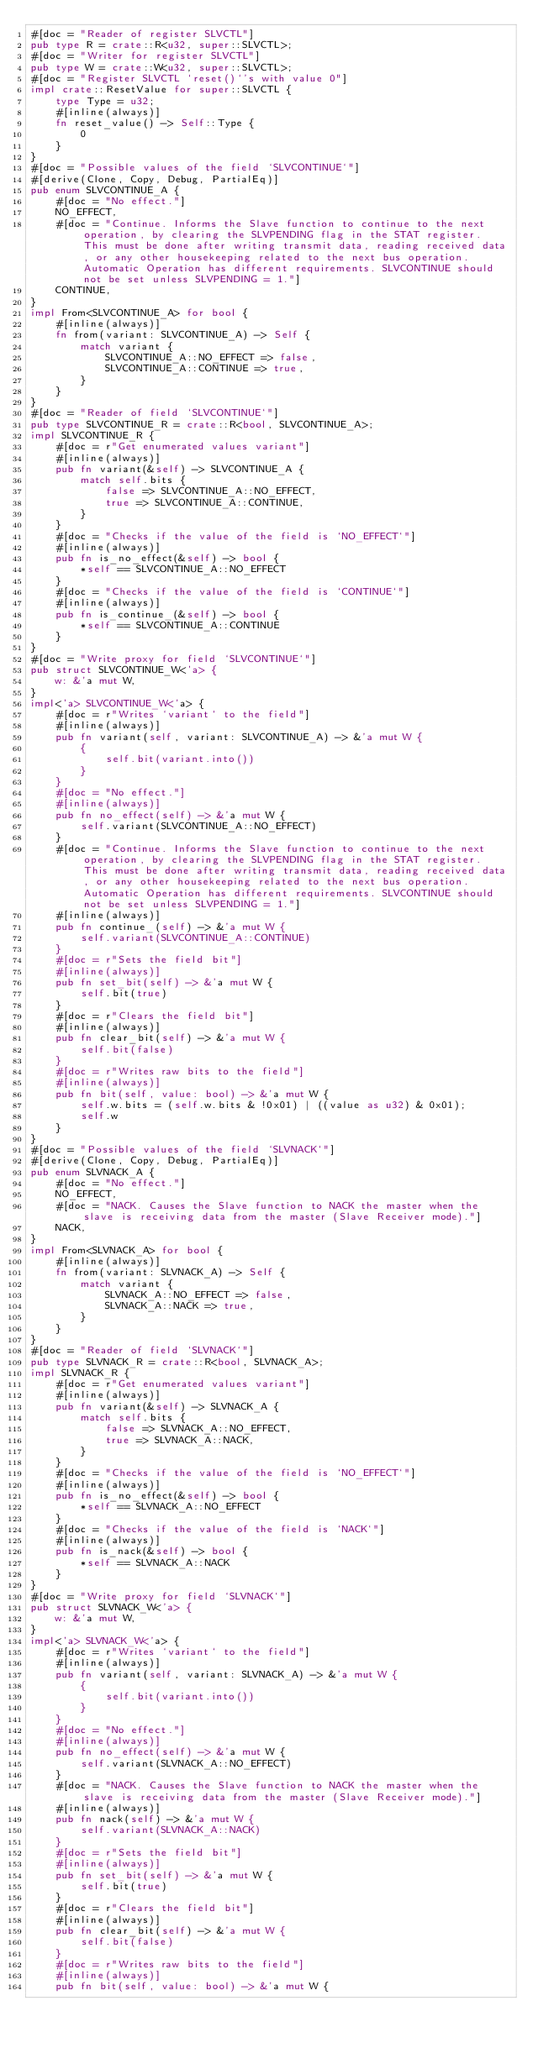Convert code to text. <code><loc_0><loc_0><loc_500><loc_500><_Rust_>#[doc = "Reader of register SLVCTL"]
pub type R = crate::R<u32, super::SLVCTL>;
#[doc = "Writer for register SLVCTL"]
pub type W = crate::W<u32, super::SLVCTL>;
#[doc = "Register SLVCTL `reset()`'s with value 0"]
impl crate::ResetValue for super::SLVCTL {
    type Type = u32;
    #[inline(always)]
    fn reset_value() -> Self::Type {
        0
    }
}
#[doc = "Possible values of the field `SLVCONTINUE`"]
#[derive(Clone, Copy, Debug, PartialEq)]
pub enum SLVCONTINUE_A {
    #[doc = "No effect."]
    NO_EFFECT,
    #[doc = "Continue. Informs the Slave function to continue to the next operation, by clearing the SLVPENDING flag in the STAT register. This must be done after writing transmit data, reading received data, or any other housekeeping related to the next bus operation. Automatic Operation has different requirements. SLVCONTINUE should not be set unless SLVPENDING = 1."]
    CONTINUE,
}
impl From<SLVCONTINUE_A> for bool {
    #[inline(always)]
    fn from(variant: SLVCONTINUE_A) -> Self {
        match variant {
            SLVCONTINUE_A::NO_EFFECT => false,
            SLVCONTINUE_A::CONTINUE => true,
        }
    }
}
#[doc = "Reader of field `SLVCONTINUE`"]
pub type SLVCONTINUE_R = crate::R<bool, SLVCONTINUE_A>;
impl SLVCONTINUE_R {
    #[doc = r"Get enumerated values variant"]
    #[inline(always)]
    pub fn variant(&self) -> SLVCONTINUE_A {
        match self.bits {
            false => SLVCONTINUE_A::NO_EFFECT,
            true => SLVCONTINUE_A::CONTINUE,
        }
    }
    #[doc = "Checks if the value of the field is `NO_EFFECT`"]
    #[inline(always)]
    pub fn is_no_effect(&self) -> bool {
        *self == SLVCONTINUE_A::NO_EFFECT
    }
    #[doc = "Checks if the value of the field is `CONTINUE`"]
    #[inline(always)]
    pub fn is_continue_(&self) -> bool {
        *self == SLVCONTINUE_A::CONTINUE
    }
}
#[doc = "Write proxy for field `SLVCONTINUE`"]
pub struct SLVCONTINUE_W<'a> {
    w: &'a mut W,
}
impl<'a> SLVCONTINUE_W<'a> {
    #[doc = r"Writes `variant` to the field"]
    #[inline(always)]
    pub fn variant(self, variant: SLVCONTINUE_A) -> &'a mut W {
        {
            self.bit(variant.into())
        }
    }
    #[doc = "No effect."]
    #[inline(always)]
    pub fn no_effect(self) -> &'a mut W {
        self.variant(SLVCONTINUE_A::NO_EFFECT)
    }
    #[doc = "Continue. Informs the Slave function to continue to the next operation, by clearing the SLVPENDING flag in the STAT register. This must be done after writing transmit data, reading received data, or any other housekeeping related to the next bus operation. Automatic Operation has different requirements. SLVCONTINUE should not be set unless SLVPENDING = 1."]
    #[inline(always)]
    pub fn continue_(self) -> &'a mut W {
        self.variant(SLVCONTINUE_A::CONTINUE)
    }
    #[doc = r"Sets the field bit"]
    #[inline(always)]
    pub fn set_bit(self) -> &'a mut W {
        self.bit(true)
    }
    #[doc = r"Clears the field bit"]
    #[inline(always)]
    pub fn clear_bit(self) -> &'a mut W {
        self.bit(false)
    }
    #[doc = r"Writes raw bits to the field"]
    #[inline(always)]
    pub fn bit(self, value: bool) -> &'a mut W {
        self.w.bits = (self.w.bits & !0x01) | ((value as u32) & 0x01);
        self.w
    }
}
#[doc = "Possible values of the field `SLVNACK`"]
#[derive(Clone, Copy, Debug, PartialEq)]
pub enum SLVNACK_A {
    #[doc = "No effect."]
    NO_EFFECT,
    #[doc = "NACK. Causes the Slave function to NACK the master when the slave is receiving data from the master (Slave Receiver mode)."]
    NACK,
}
impl From<SLVNACK_A> for bool {
    #[inline(always)]
    fn from(variant: SLVNACK_A) -> Self {
        match variant {
            SLVNACK_A::NO_EFFECT => false,
            SLVNACK_A::NACK => true,
        }
    }
}
#[doc = "Reader of field `SLVNACK`"]
pub type SLVNACK_R = crate::R<bool, SLVNACK_A>;
impl SLVNACK_R {
    #[doc = r"Get enumerated values variant"]
    #[inline(always)]
    pub fn variant(&self) -> SLVNACK_A {
        match self.bits {
            false => SLVNACK_A::NO_EFFECT,
            true => SLVNACK_A::NACK,
        }
    }
    #[doc = "Checks if the value of the field is `NO_EFFECT`"]
    #[inline(always)]
    pub fn is_no_effect(&self) -> bool {
        *self == SLVNACK_A::NO_EFFECT
    }
    #[doc = "Checks if the value of the field is `NACK`"]
    #[inline(always)]
    pub fn is_nack(&self) -> bool {
        *self == SLVNACK_A::NACK
    }
}
#[doc = "Write proxy for field `SLVNACK`"]
pub struct SLVNACK_W<'a> {
    w: &'a mut W,
}
impl<'a> SLVNACK_W<'a> {
    #[doc = r"Writes `variant` to the field"]
    #[inline(always)]
    pub fn variant(self, variant: SLVNACK_A) -> &'a mut W {
        {
            self.bit(variant.into())
        }
    }
    #[doc = "No effect."]
    #[inline(always)]
    pub fn no_effect(self) -> &'a mut W {
        self.variant(SLVNACK_A::NO_EFFECT)
    }
    #[doc = "NACK. Causes the Slave function to NACK the master when the slave is receiving data from the master (Slave Receiver mode)."]
    #[inline(always)]
    pub fn nack(self) -> &'a mut W {
        self.variant(SLVNACK_A::NACK)
    }
    #[doc = r"Sets the field bit"]
    #[inline(always)]
    pub fn set_bit(self) -> &'a mut W {
        self.bit(true)
    }
    #[doc = r"Clears the field bit"]
    #[inline(always)]
    pub fn clear_bit(self) -> &'a mut W {
        self.bit(false)
    }
    #[doc = r"Writes raw bits to the field"]
    #[inline(always)]
    pub fn bit(self, value: bool) -> &'a mut W {</code> 